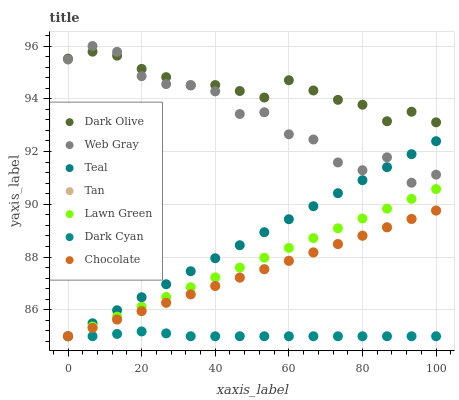Does Dark Cyan have the minimum area under the curve?
Answer yes or no. Yes. Does Dark Olive have the maximum area under the curve?
Answer yes or no. Yes. Does Web Gray have the minimum area under the curve?
Answer yes or no. No. Does Web Gray have the maximum area under the curve?
Answer yes or no. No. Is Tan the smoothest?
Answer yes or no. Yes. Is Web Gray the roughest?
Answer yes or no. Yes. Is Dark Olive the smoothest?
Answer yes or no. No. Is Dark Olive the roughest?
Answer yes or no. No. Does Lawn Green have the lowest value?
Answer yes or no. Yes. Does Web Gray have the lowest value?
Answer yes or no. No. Does Web Gray have the highest value?
Answer yes or no. Yes. Does Dark Olive have the highest value?
Answer yes or no. No. Is Teal less than Dark Olive?
Answer yes or no. Yes. Is Dark Olive greater than Lawn Green?
Answer yes or no. Yes. Does Teal intersect Web Gray?
Answer yes or no. Yes. Is Teal less than Web Gray?
Answer yes or no. No. Is Teal greater than Web Gray?
Answer yes or no. No. Does Teal intersect Dark Olive?
Answer yes or no. No. 